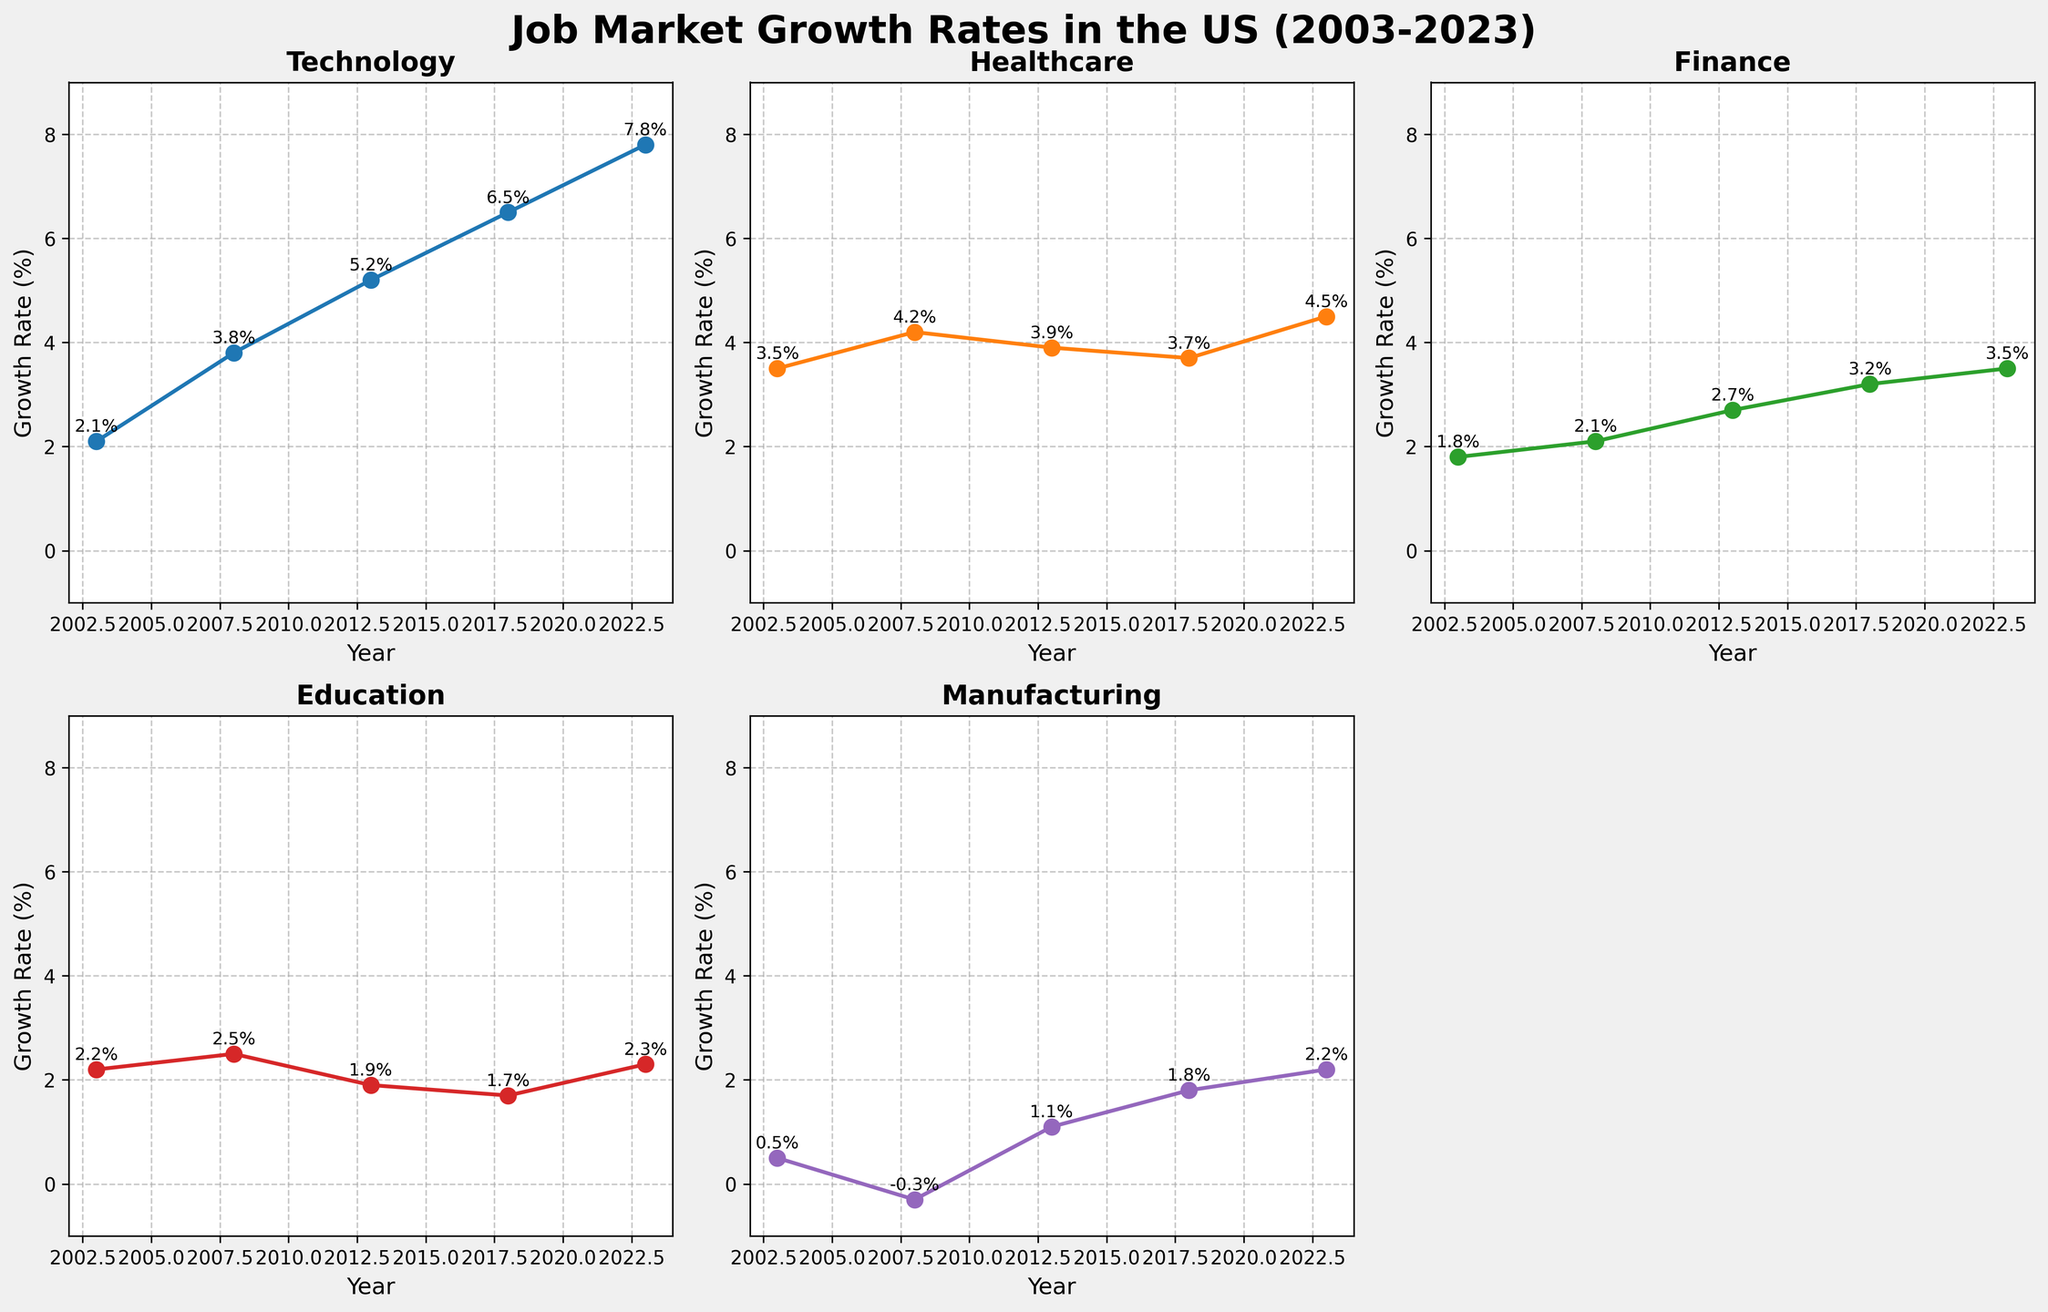What is the title of the figure? The title is displayed at the top of the figure. It reads "Job Market Growth Rates in the US (2003-2023)".
Answer: Job Market Growth Rates in the US (2003-2023) What color is used for the Technology industry line? The color can be identified by looking at the Technology subplot. The line for Technology is color-coded with a shade of blue.
Answer: Blue Which year shows the highest growth rate for the Finance industry? Look at the Finance subplot and find the point with the highest y-value. It is 3.5% in the year 2023.
Answer: 2023 How many data points are there for each industry? Each industry has data points marked for the years: 2003, 2008, 2013, 2018, and 2023. This sums to 5 data points per industry.
Answer: 5 What is the average growth rate of the Healthcare industry over the 20-year period? Sum the growth rates for Healthcare (3.5 + 4.2 + 3.9 + 3.7 + 4.5) and divide by the number of data points (5). The average is (3.5 + 4.2 + 3.9 + 3.7 + 4.5) / 5 = 3.96%.
Answer: 3.96% How does the Manufacturing industry's growth rate in 2008 compare to that in 2013? In the Manufacturing subplot, the growth rate in 2008 is -0.3%, and in 2013 it is 1.1%. The rate increased by (1.1 - (-0.3)) = 1.4%.
Answer: Increased by 1.4% Which industry had a negative growth rate in any of the years displayed? By examining each subplot, the Manufacturing subplot shows a negative growth rate of -0.3% in the year 2008.
Answer: Manufacturing What is the difference in growth rates between Technology and Education in 2023? The Technology growth rate in 2023 is 7.8%, and for Education, it is 2.3%. The difference is 7.8% - 2.3% = 5.5%.
Answer: 5.5% Between 2013 and 2018, which industry saw the largest increase in growth rate? Calculate the differences for each industry: Technology (6.5 - 5.2) = 1.3, Healthcare (3.7 - 3.9) = -0.2, Finance (3.2 - 2.7) = 0.5, Education (1.7 - 1.9) = -0.2, Manufacturing (1.8 - 1.1) = 0.7. The largest increase is in Technology at 1.3%.
Answer: Technology Which industry had the most stable growth rate (the least variation) over the 20 years? Examine the fluctuations in each subplot. Healthcare shows smaller variations around 3.5 to 4.5%, implying it is the most stable.
Answer: Healthcare 